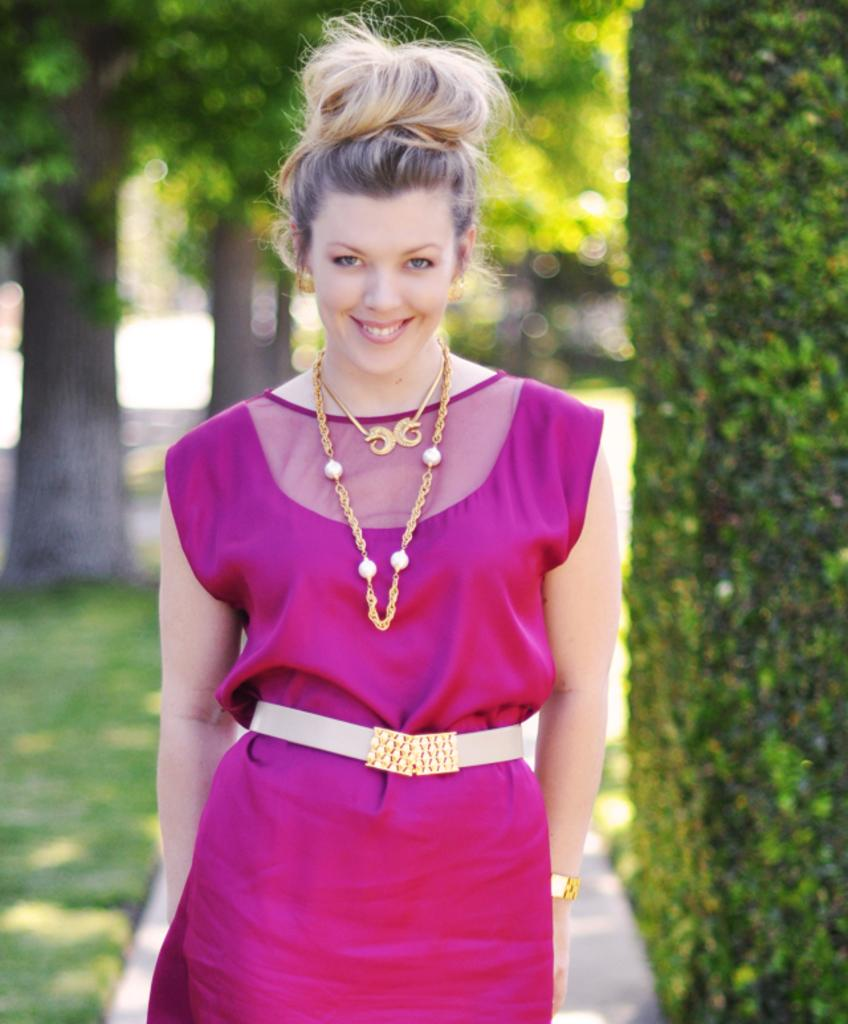Who is present in the image? There is a woman in the image. What is the woman wearing? The woman is wearing a pink dress. What is the woman's facial expression? The woman is smiling. What can be seen in the background of the image? There are trees and grass in the background of the image. What advice does the woman give in the image? There is no indication in the image that the woman is giving advice, as her actions or words are not depicted. 